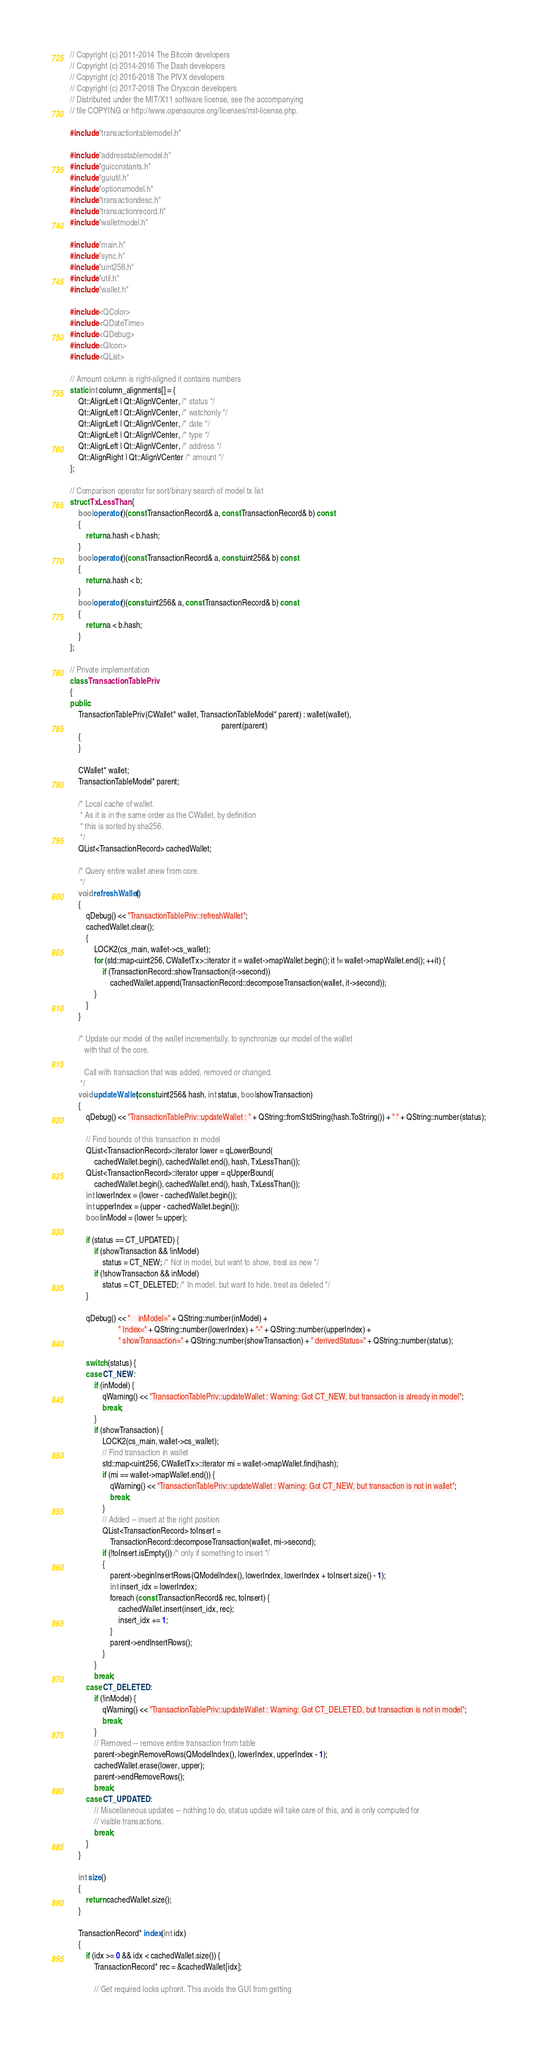Convert code to text. <code><loc_0><loc_0><loc_500><loc_500><_C++_>// Copyright (c) 2011-2014 The Bitcoin developers
// Copyright (c) 2014-2016 The Dash developers
// Copyright (c) 2016-2018 The PIVX developers
// Copyright (c) 2017-2018 The Oryxcoin developers
// Distributed under the MIT/X11 software license, see the accompanying
// file COPYING or http://www.opensource.org/licenses/mit-license.php.

#include "transactiontablemodel.h"

#include "addresstablemodel.h"
#include "guiconstants.h"
#include "guiutil.h"
#include "optionsmodel.h"
#include "transactiondesc.h"
#include "transactionrecord.h"
#include "walletmodel.h"

#include "main.h"
#include "sync.h"
#include "uint256.h"
#include "util.h"
#include "wallet.h"

#include <QColor>
#include <QDateTime>
#include <QDebug>
#include <QIcon>
#include <QList>

// Amount column is right-aligned it contains numbers
static int column_alignments[] = {
    Qt::AlignLeft | Qt::AlignVCenter, /* status */
    Qt::AlignLeft | Qt::AlignVCenter, /* watchonly */
    Qt::AlignLeft | Qt::AlignVCenter, /* date */
    Qt::AlignLeft | Qt::AlignVCenter, /* type */
    Qt::AlignLeft | Qt::AlignVCenter, /* address */
    Qt::AlignRight | Qt::AlignVCenter /* amount */
};

// Comparison operator for sort/binary search of model tx list
struct TxLessThan {
    bool operator()(const TransactionRecord& a, const TransactionRecord& b) const
    {
        return a.hash < b.hash;
    }
    bool operator()(const TransactionRecord& a, const uint256& b) const
    {
        return a.hash < b;
    }
    bool operator()(const uint256& a, const TransactionRecord& b) const
    {
        return a < b.hash;
    }
};

// Private implementation
class TransactionTablePriv
{
public:
    TransactionTablePriv(CWallet* wallet, TransactionTableModel* parent) : wallet(wallet),
                                                                           parent(parent)
    {
    }

    CWallet* wallet;
    TransactionTableModel* parent;

    /* Local cache of wallet.
     * As it is in the same order as the CWallet, by definition
     * this is sorted by sha256.
     */
    QList<TransactionRecord> cachedWallet;

    /* Query entire wallet anew from core.
     */
    void refreshWallet()
    {
        qDebug() << "TransactionTablePriv::refreshWallet";
        cachedWallet.clear();
        {
            LOCK2(cs_main, wallet->cs_wallet);
            for (std::map<uint256, CWalletTx>::iterator it = wallet->mapWallet.begin(); it != wallet->mapWallet.end(); ++it) {
                if (TransactionRecord::showTransaction(it->second))
                    cachedWallet.append(TransactionRecord::decomposeTransaction(wallet, it->second));
            }
        }
    }

    /* Update our model of the wallet incrementally, to synchronize our model of the wallet
       with that of the core.

       Call with transaction that was added, removed or changed.
     */
    void updateWallet(const uint256& hash, int status, bool showTransaction)
    {
        qDebug() << "TransactionTablePriv::updateWallet : " + QString::fromStdString(hash.ToString()) + " " + QString::number(status);

        // Find bounds of this transaction in model
        QList<TransactionRecord>::iterator lower = qLowerBound(
            cachedWallet.begin(), cachedWallet.end(), hash, TxLessThan());
        QList<TransactionRecord>::iterator upper = qUpperBound(
            cachedWallet.begin(), cachedWallet.end(), hash, TxLessThan());
        int lowerIndex = (lower - cachedWallet.begin());
        int upperIndex = (upper - cachedWallet.begin());
        bool inModel = (lower != upper);

        if (status == CT_UPDATED) {
            if (showTransaction && !inModel)
                status = CT_NEW; /* Not in model, but want to show, treat as new */
            if (!showTransaction && inModel)
                status = CT_DELETED; /* In model, but want to hide, treat as deleted */
        }

        qDebug() << "    inModel=" + QString::number(inModel) +
                        " Index=" + QString::number(lowerIndex) + "-" + QString::number(upperIndex) +
                        " showTransaction=" + QString::number(showTransaction) + " derivedStatus=" + QString::number(status);

        switch (status) {
        case CT_NEW:
            if (inModel) {
                qWarning() << "TransactionTablePriv::updateWallet : Warning: Got CT_NEW, but transaction is already in model";
                break;
            }
            if (showTransaction) {
                LOCK2(cs_main, wallet->cs_wallet);
                // Find transaction in wallet
                std::map<uint256, CWalletTx>::iterator mi = wallet->mapWallet.find(hash);
                if (mi == wallet->mapWallet.end()) {
                    qWarning() << "TransactionTablePriv::updateWallet : Warning: Got CT_NEW, but transaction is not in wallet";
                    break;
                }
                // Added -- insert at the right position
                QList<TransactionRecord> toInsert =
                    TransactionRecord::decomposeTransaction(wallet, mi->second);
                if (!toInsert.isEmpty()) /* only if something to insert */
                {
                    parent->beginInsertRows(QModelIndex(), lowerIndex, lowerIndex + toInsert.size() - 1);
                    int insert_idx = lowerIndex;
                    foreach (const TransactionRecord& rec, toInsert) {
                        cachedWallet.insert(insert_idx, rec);
                        insert_idx += 1;
                    }
                    parent->endInsertRows();
                }
            }
            break;
        case CT_DELETED:
            if (!inModel) {
                qWarning() << "TransactionTablePriv::updateWallet : Warning: Got CT_DELETED, but transaction is not in model";
                break;
            }
            // Removed -- remove entire transaction from table
            parent->beginRemoveRows(QModelIndex(), lowerIndex, upperIndex - 1);
            cachedWallet.erase(lower, upper);
            parent->endRemoveRows();
            break;
        case CT_UPDATED:
            // Miscellaneous updates -- nothing to do, status update will take care of this, and is only computed for
            // visible transactions.
            break;
        }
    }

    int size()
    {
        return cachedWallet.size();
    }

    TransactionRecord* index(int idx)
    {
        if (idx >= 0 && idx < cachedWallet.size()) {
            TransactionRecord* rec = &cachedWallet[idx];

            // Get required locks upfront. This avoids the GUI from getting</code> 